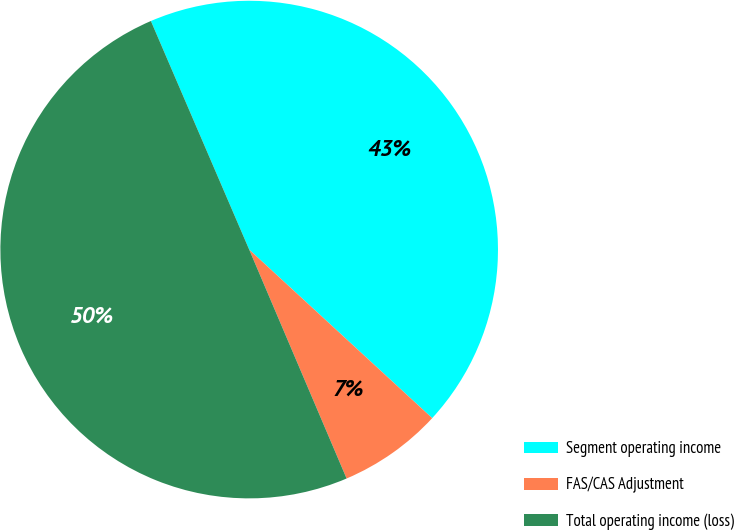Convert chart. <chart><loc_0><loc_0><loc_500><loc_500><pie_chart><fcel>Segment operating income<fcel>FAS/CAS Adjustment<fcel>Total operating income (loss)<nl><fcel>43.31%<fcel>6.75%<fcel>49.94%<nl></chart> 